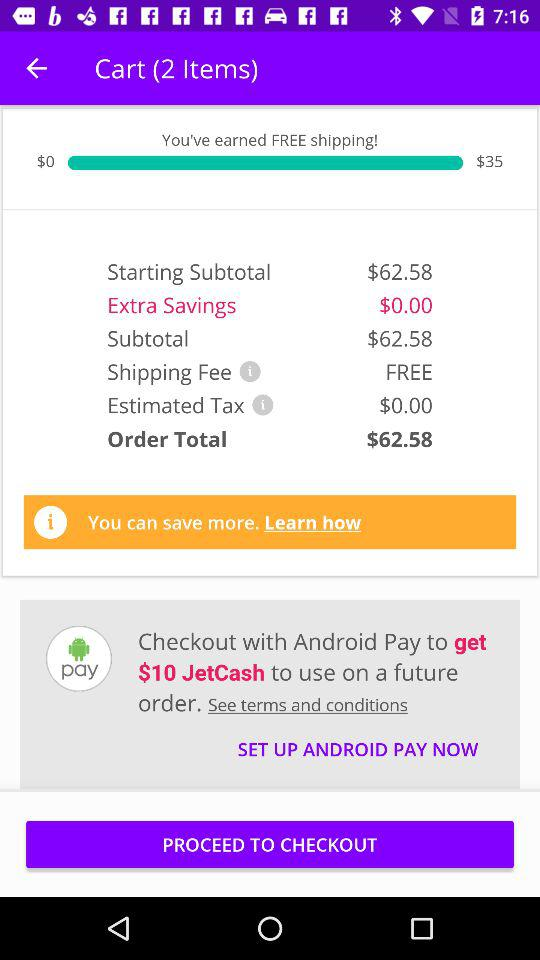What are the items that are being purchased?
When the provided information is insufficient, respond with <no answer>. <no answer> 